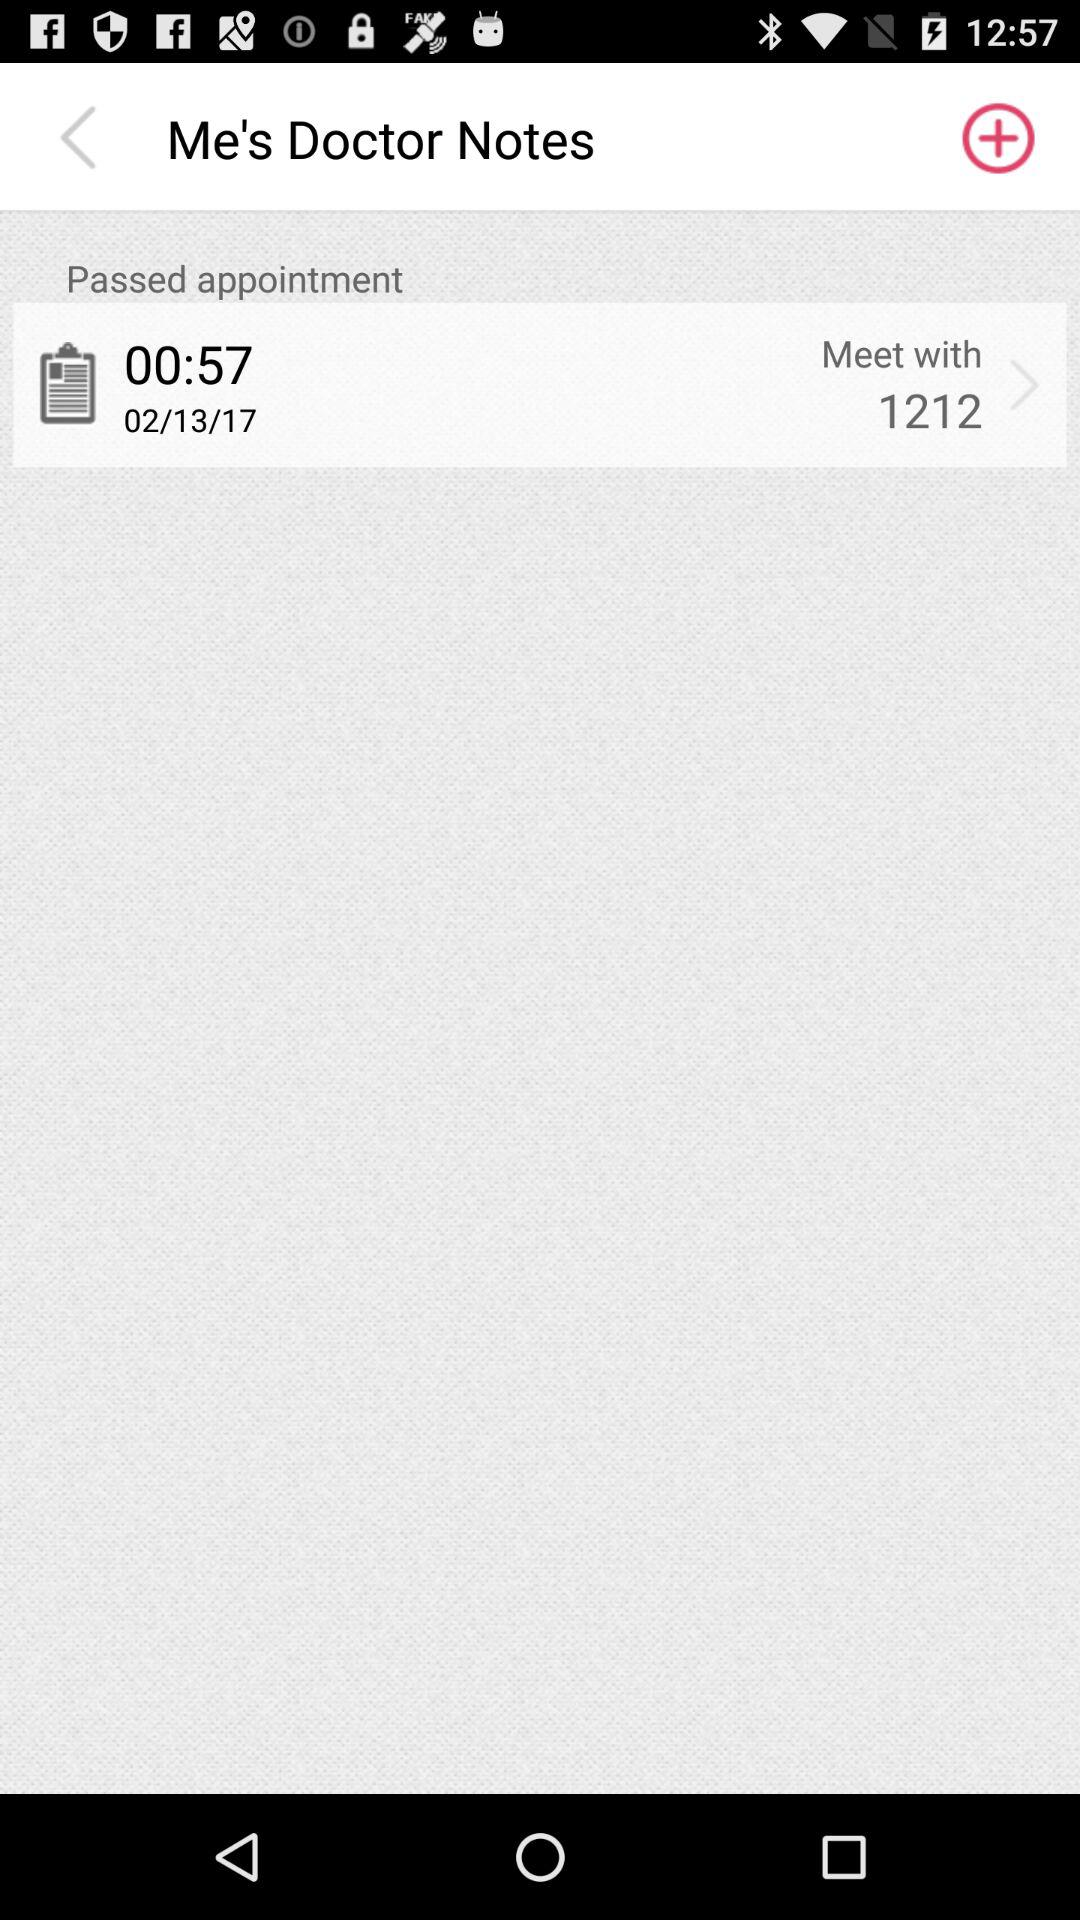On what date is the doctor's appointment? The doctor's appointment is on February 13, 2017. 